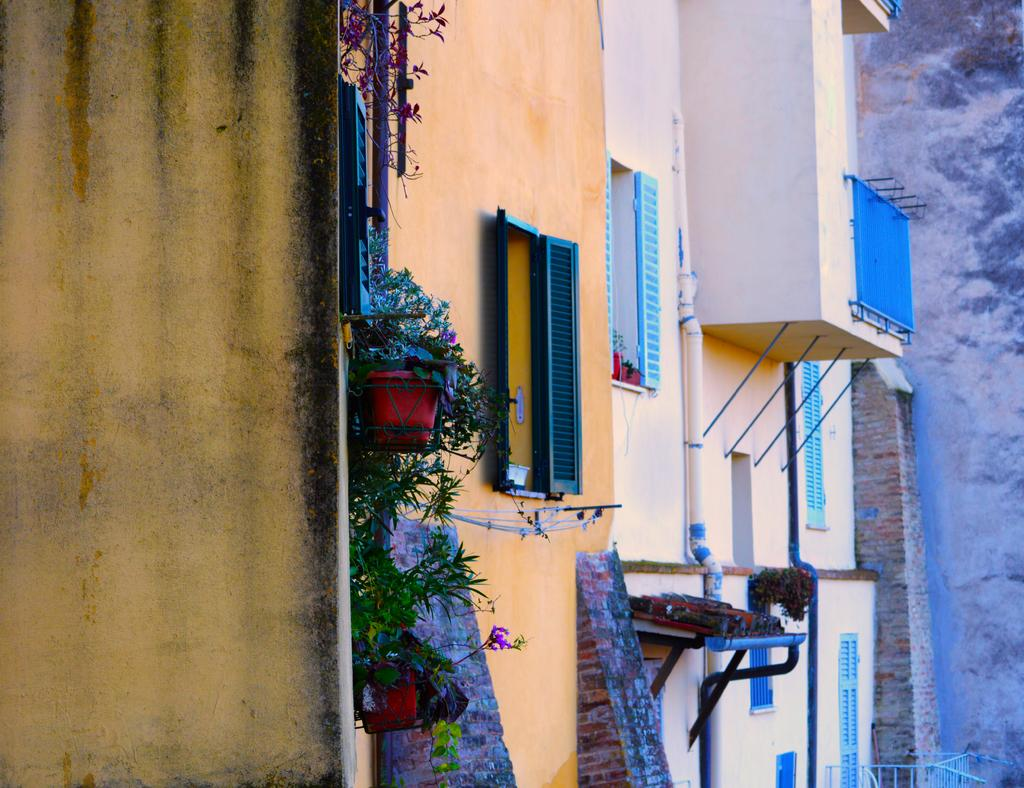What type of structure is in the image? There is a building in the image. What type of vegetation is present in the image? Creepers are present in the image. What objects are used for planting in the image? There are flower pots in the image. What type of infrastructure is visible in the image? Pipelines are visible in the image. What architectural feature can be seen in the building? Windows are observable in the image. What example of regret can be seen in the image? There is no example of regret present in the image. 